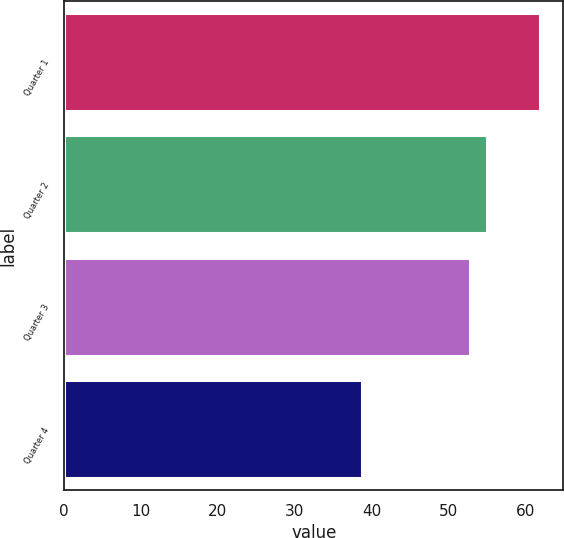Convert chart to OTSL. <chart><loc_0><loc_0><loc_500><loc_500><bar_chart><fcel>Quarter 1<fcel>Quarter 2<fcel>Quarter 3<fcel>Quarter 4<nl><fcel>61.88<fcel>55.09<fcel>52.78<fcel>38.81<nl></chart> 